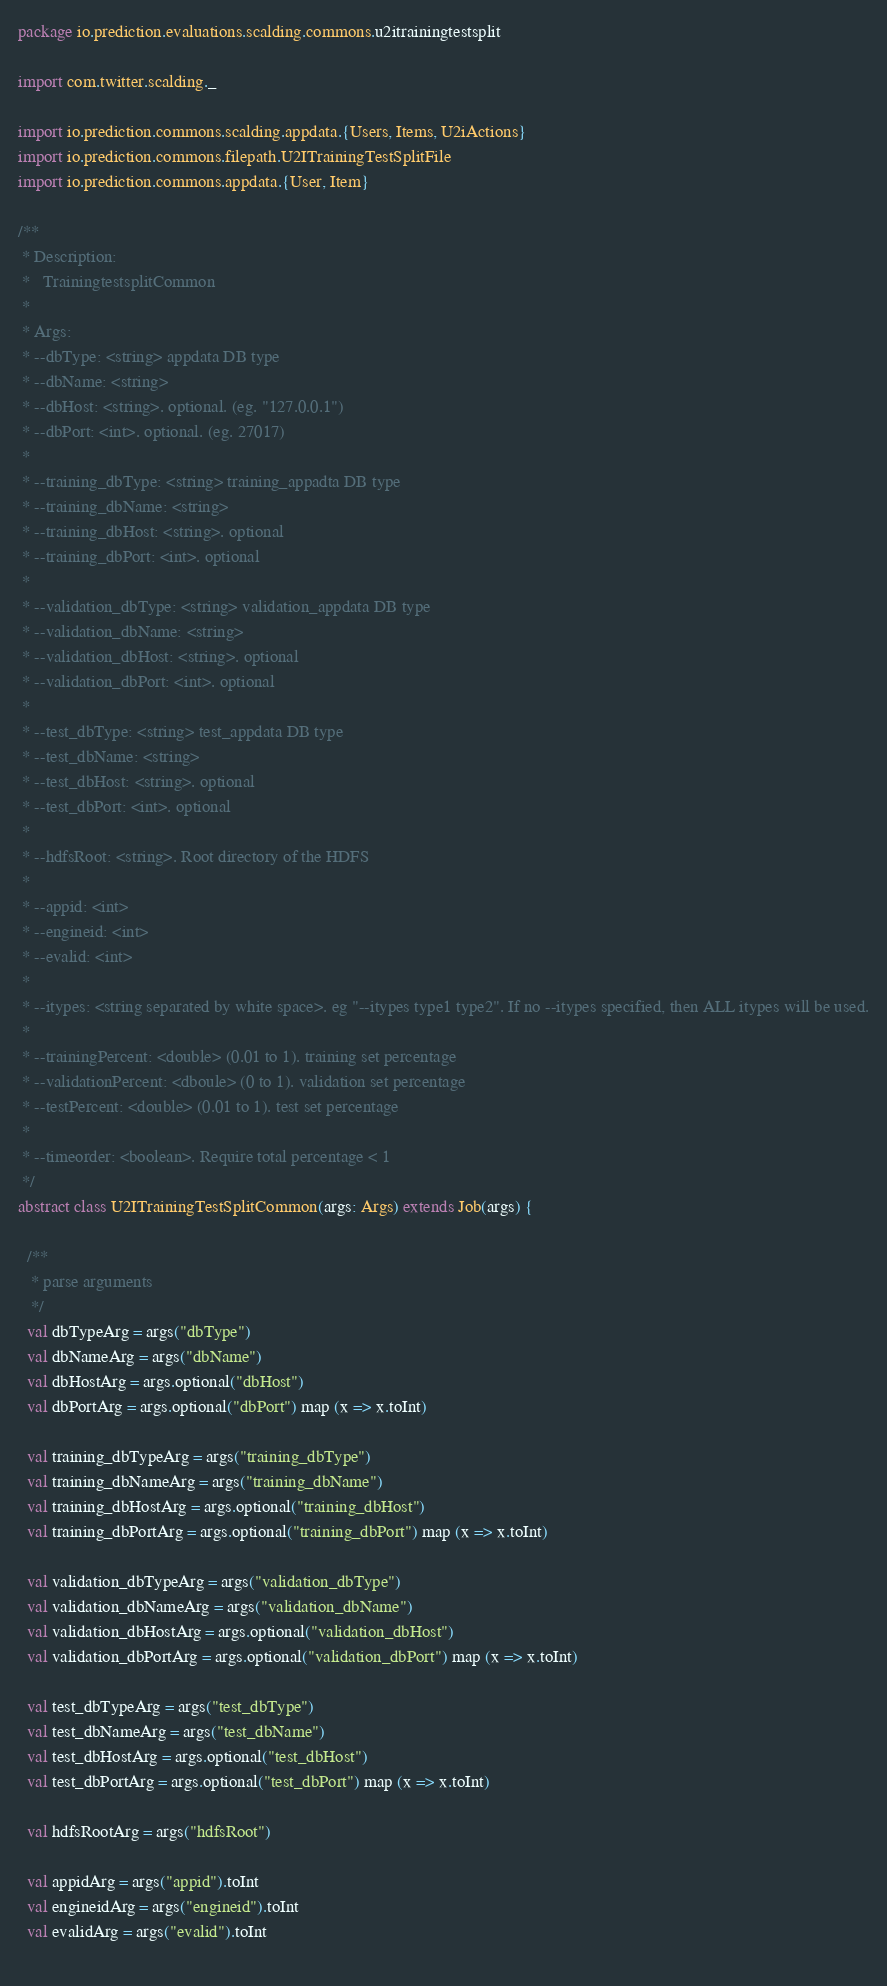Convert code to text. <code><loc_0><loc_0><loc_500><loc_500><_Scala_>package io.prediction.evaluations.scalding.commons.u2itrainingtestsplit

import com.twitter.scalding._

import io.prediction.commons.scalding.appdata.{Users, Items, U2iActions}
import io.prediction.commons.filepath.U2ITrainingTestSplitFile
import io.prediction.commons.appdata.{User, Item}

/**
 * Description:
 *   TrainingtestsplitCommon
 *
 * Args: 
 * --dbType: <string> appdata DB type
 * --dbName: <string>
 * --dbHost: <string>. optional. (eg. "127.0.0.1")
 * --dbPort: <int>. optional. (eg. 27017)
 *
 * --training_dbType: <string> training_appadta DB type
 * --training_dbName: <string>
 * --training_dbHost: <string>. optional
 * --training_dbPort: <int>. optional
 * 
 * --validation_dbType: <string> validation_appdata DB type
 * --validation_dbName: <string>
 * --validation_dbHost: <string>. optional
 * --validation_dbPort: <int>. optional
 *
 * --test_dbType: <string> test_appdata DB type
 * --test_dbName: <string>
 * --test_dbHost: <string>. optional
 * --test_dbPort: <int>. optional
 *
 * --hdfsRoot: <string>. Root directory of the HDFS
 * 
 * --appid: <int>
 * --engineid: <int>
 * --evalid: <int>
 *
 * --itypes: <string separated by white space>. eg "--itypes type1 type2". If no --itypes specified, then ALL itypes will be used.
 *
 * --trainingPercent: <double> (0.01 to 1). training set percentage
 * --validationPercent: <dboule> (0 to 1). validation set percentage
 * --testPercent: <double> (0.01 to 1). test set percentage
 *
 * --timeorder: <boolean>. Require total percentage < 1
 */
abstract class U2ITrainingTestSplitCommon(args: Args) extends Job(args) {

  /**
   * parse arguments
   */
  val dbTypeArg = args("dbType")
  val dbNameArg = args("dbName")
  val dbHostArg = args.optional("dbHost")
  val dbPortArg = args.optional("dbPort") map (x => x.toInt) 
  
  val training_dbTypeArg = args("training_dbType")
  val training_dbNameArg = args("training_dbName")
  val training_dbHostArg = args.optional("training_dbHost")
  val training_dbPortArg = args.optional("training_dbPort") map (x => x.toInt) 
  
  val validation_dbTypeArg = args("validation_dbType")
  val validation_dbNameArg = args("validation_dbName")
  val validation_dbHostArg = args.optional("validation_dbHost")
  val validation_dbPortArg = args.optional("validation_dbPort") map (x => x.toInt) 

  val test_dbTypeArg = args("test_dbType")
  val test_dbNameArg = args("test_dbName")
  val test_dbHostArg = args.optional("test_dbHost")
  val test_dbPortArg = args.optional("test_dbPort") map (x => x.toInt) 

  val hdfsRootArg = args("hdfsRoot")
  
  val appidArg = args("appid").toInt
  val engineidArg = args("engineid").toInt
  val evalidArg = args("evalid").toInt
  </code> 